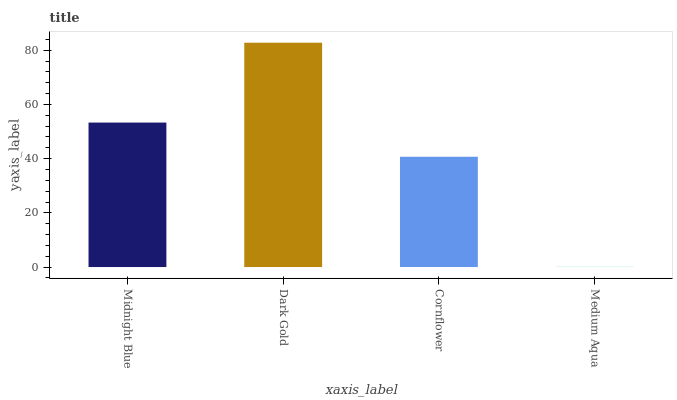Is Medium Aqua the minimum?
Answer yes or no. Yes. Is Dark Gold the maximum?
Answer yes or no. Yes. Is Cornflower the minimum?
Answer yes or no. No. Is Cornflower the maximum?
Answer yes or no. No. Is Dark Gold greater than Cornflower?
Answer yes or no. Yes. Is Cornflower less than Dark Gold?
Answer yes or no. Yes. Is Cornflower greater than Dark Gold?
Answer yes or no. No. Is Dark Gold less than Cornflower?
Answer yes or no. No. Is Midnight Blue the high median?
Answer yes or no. Yes. Is Cornflower the low median?
Answer yes or no. Yes. Is Cornflower the high median?
Answer yes or no. No. Is Dark Gold the low median?
Answer yes or no. No. 